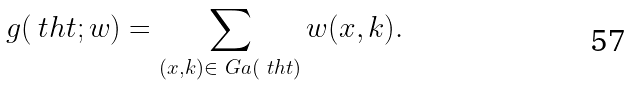Convert formula to latex. <formula><loc_0><loc_0><loc_500><loc_500>g ( \ t h t ; w ) = \sum _ { ( x , k ) \in \ G a ( \ t h t ) } w ( x , k ) .</formula> 